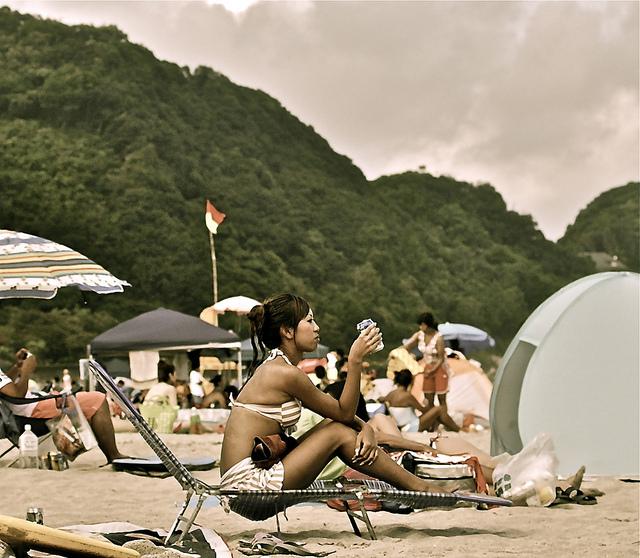Why is there a tent on the beach?
Write a very short answer. Shade. Is it cold here?
Answer briefly. No. What pattern is the woman's bikini top?
Quick response, please. Striped. 